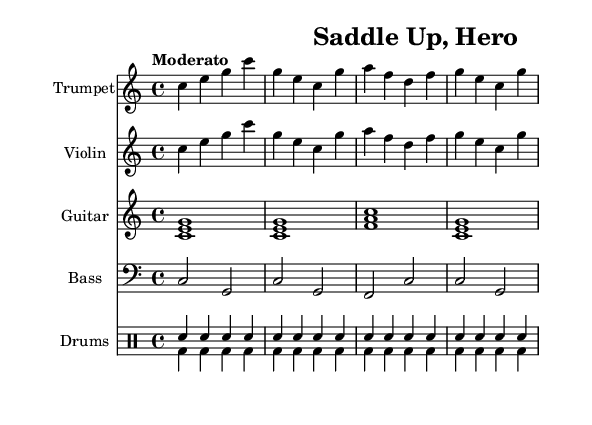What is the key signature of this music? The key signature is indicated at the beginning of the music. It shows no sharps or flats, which corresponds to C major.
Answer: C major What is the time signature of the piece? The time signature is found at the beginning of the score, represented by the numbers indicating beats per measure. Here, it shows 4 over 4, meaning there are four beats in each measure.
Answer: 4/4 What is the tempo marking for this score? The tempo is specified above the music, indicating how fast the piece should be played. It reads "Moderato," suggesting a moderate speed.
Answer: Moderato How many measures are there in total? By counting the measures in each staff, we determine there are a total of 8 measures across the various parts of the score, as each line shows 4 measures.
Answer: 8 Which instruments are included in the score? The instruments are listed at the beginning of each staff, showing the parts for trumpet, violin, guitar, bass, and drums.
Answer: Trumpet, Violin, Guitar, Bass, Drums What rhythmic pattern is used for the snare drum? The snare drum part uses a consistent pattern throughout the score, indicated by four eighth notes (sn) in each measure.
Answer: Eighth notes Which chord is played in the guitar for the first measure? The chord in the guitar part for the first measure can be identified by looking at the notes indicated. The notes c, e, and g identify it as a C major chord.
Answer: C major 